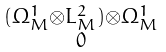Convert formula to latex. <formula><loc_0><loc_0><loc_500><loc_500>\begin{smallmatrix} ( \Omega ^ { 1 } _ { M } \otimes L _ { M } ^ { 2 } ) \otimes \Omega ^ { 1 } _ { M } \\ 0 \end{smallmatrix}</formula> 